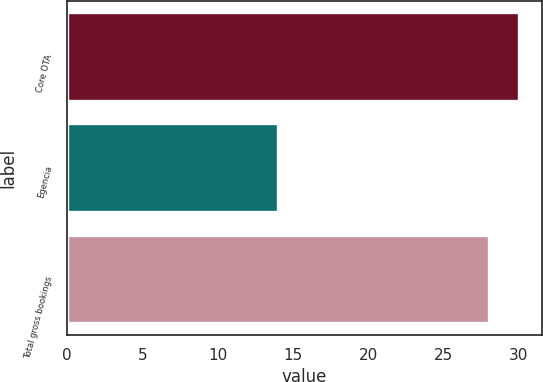<chart> <loc_0><loc_0><loc_500><loc_500><bar_chart><fcel>Core OTA<fcel>Egencia<fcel>Total gross bookings<nl><fcel>30<fcel>14<fcel>28<nl></chart> 